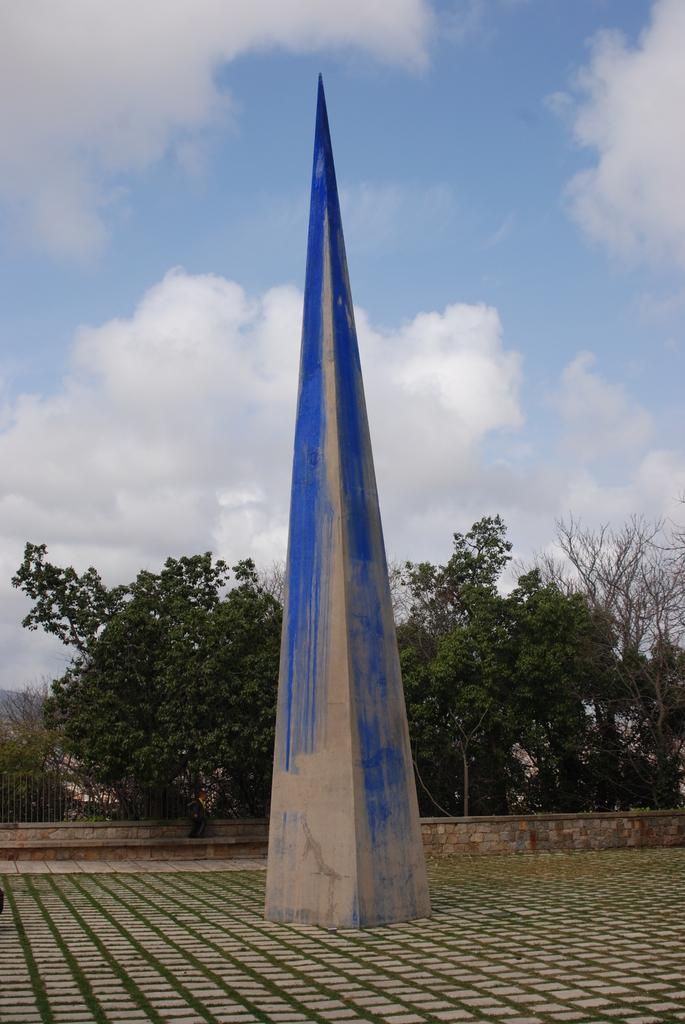What is the main structure in the image? There is a pyramid in the image. On what surface is the pyramid placed? The pyramid is on a surface. What can be seen in the background of the image? There are trees, a fence, and the sky visible in the background of the image. What is the condition of the sky in the image? Clouds are present in the sky. What type of pencil can be seen in the image? There is no pencil present in the image. How does the wind affect the pyramid in the image? The image does not show any wind or movement of the pyramid, so it cannot be determined how the wind affects it. 